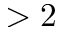Convert formula to latex. <formula><loc_0><loc_0><loc_500><loc_500>> 2</formula> 